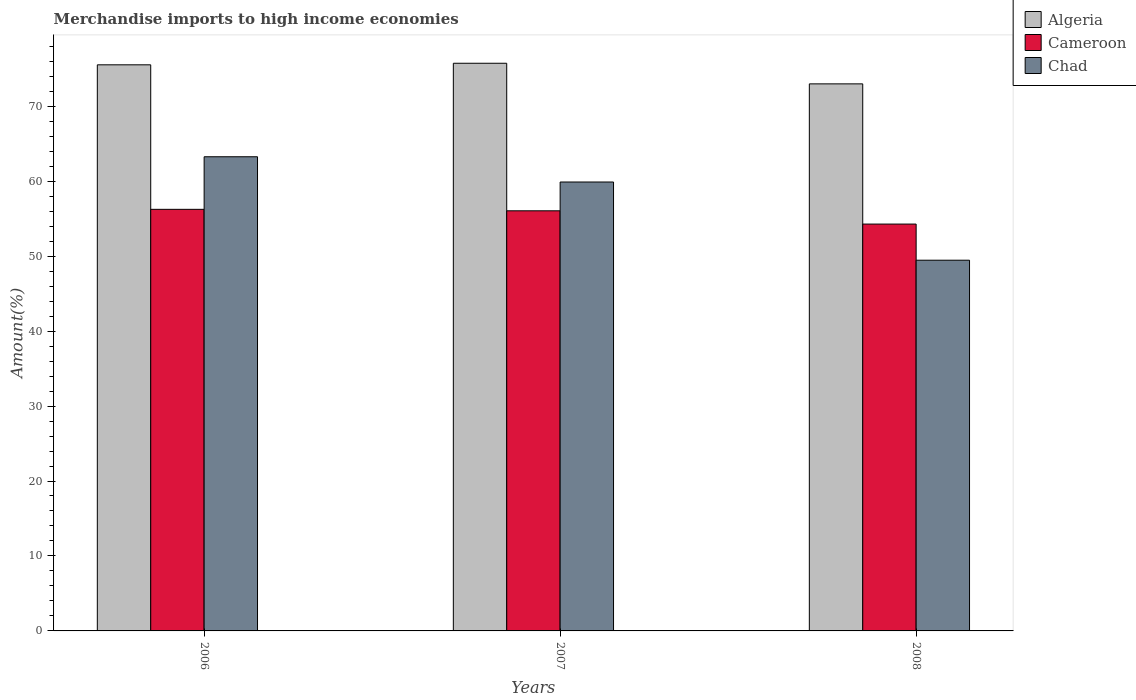How many different coloured bars are there?
Give a very brief answer. 3. How many bars are there on the 3rd tick from the left?
Make the answer very short. 3. How many bars are there on the 3rd tick from the right?
Give a very brief answer. 3. What is the percentage of amount earned from merchandise imports in Cameroon in 2006?
Your response must be concise. 56.24. Across all years, what is the maximum percentage of amount earned from merchandise imports in Algeria?
Provide a short and direct response. 75.73. Across all years, what is the minimum percentage of amount earned from merchandise imports in Cameroon?
Your response must be concise. 54.28. In which year was the percentage of amount earned from merchandise imports in Algeria maximum?
Ensure brevity in your answer.  2007. What is the total percentage of amount earned from merchandise imports in Cameroon in the graph?
Ensure brevity in your answer.  166.56. What is the difference between the percentage of amount earned from merchandise imports in Cameroon in 2006 and that in 2008?
Make the answer very short. 1.97. What is the difference between the percentage of amount earned from merchandise imports in Algeria in 2007 and the percentage of amount earned from merchandise imports in Chad in 2006?
Your answer should be compact. 12.47. What is the average percentage of amount earned from merchandise imports in Cameroon per year?
Ensure brevity in your answer.  55.52. In the year 2007, what is the difference between the percentage of amount earned from merchandise imports in Cameroon and percentage of amount earned from merchandise imports in Algeria?
Your response must be concise. -19.68. What is the ratio of the percentage of amount earned from merchandise imports in Cameroon in 2006 to that in 2007?
Give a very brief answer. 1. Is the difference between the percentage of amount earned from merchandise imports in Cameroon in 2006 and 2007 greater than the difference between the percentage of amount earned from merchandise imports in Algeria in 2006 and 2007?
Offer a very short reply. Yes. What is the difference between the highest and the second highest percentage of amount earned from merchandise imports in Chad?
Provide a succinct answer. 3.37. What is the difference between the highest and the lowest percentage of amount earned from merchandise imports in Algeria?
Offer a very short reply. 2.75. In how many years, is the percentage of amount earned from merchandise imports in Algeria greater than the average percentage of amount earned from merchandise imports in Algeria taken over all years?
Ensure brevity in your answer.  2. Is the sum of the percentage of amount earned from merchandise imports in Chad in 2007 and 2008 greater than the maximum percentage of amount earned from merchandise imports in Algeria across all years?
Offer a terse response. Yes. What does the 3rd bar from the left in 2007 represents?
Your answer should be very brief. Chad. What does the 3rd bar from the right in 2008 represents?
Ensure brevity in your answer.  Algeria. Is it the case that in every year, the sum of the percentage of amount earned from merchandise imports in Chad and percentage of amount earned from merchandise imports in Algeria is greater than the percentage of amount earned from merchandise imports in Cameroon?
Ensure brevity in your answer.  Yes. Are all the bars in the graph horizontal?
Give a very brief answer. No. How many years are there in the graph?
Your answer should be compact. 3. Are the values on the major ticks of Y-axis written in scientific E-notation?
Keep it short and to the point. No. Does the graph contain any zero values?
Offer a terse response. No. How are the legend labels stacked?
Keep it short and to the point. Vertical. What is the title of the graph?
Keep it short and to the point. Merchandise imports to high income economies. Does "Indonesia" appear as one of the legend labels in the graph?
Provide a succinct answer. No. What is the label or title of the Y-axis?
Your response must be concise. Amount(%). What is the Amount(%) in Algeria in 2006?
Ensure brevity in your answer.  75.52. What is the Amount(%) in Cameroon in 2006?
Your response must be concise. 56.24. What is the Amount(%) of Chad in 2006?
Keep it short and to the point. 63.26. What is the Amount(%) of Algeria in 2007?
Make the answer very short. 75.73. What is the Amount(%) in Cameroon in 2007?
Offer a terse response. 56.05. What is the Amount(%) in Chad in 2007?
Provide a succinct answer. 59.89. What is the Amount(%) in Algeria in 2008?
Offer a very short reply. 72.98. What is the Amount(%) of Cameroon in 2008?
Make the answer very short. 54.28. What is the Amount(%) of Chad in 2008?
Offer a terse response. 49.45. Across all years, what is the maximum Amount(%) of Algeria?
Give a very brief answer. 75.73. Across all years, what is the maximum Amount(%) of Cameroon?
Give a very brief answer. 56.24. Across all years, what is the maximum Amount(%) in Chad?
Provide a succinct answer. 63.26. Across all years, what is the minimum Amount(%) in Algeria?
Offer a terse response. 72.98. Across all years, what is the minimum Amount(%) of Cameroon?
Your answer should be very brief. 54.28. Across all years, what is the minimum Amount(%) in Chad?
Give a very brief answer. 49.45. What is the total Amount(%) in Algeria in the graph?
Provide a succinct answer. 224.23. What is the total Amount(%) of Cameroon in the graph?
Offer a terse response. 166.56. What is the total Amount(%) in Chad in the graph?
Provide a short and direct response. 172.6. What is the difference between the Amount(%) in Algeria in 2006 and that in 2007?
Provide a succinct answer. -0.21. What is the difference between the Amount(%) of Cameroon in 2006 and that in 2007?
Your answer should be compact. 0.2. What is the difference between the Amount(%) in Chad in 2006 and that in 2007?
Offer a terse response. 3.37. What is the difference between the Amount(%) in Algeria in 2006 and that in 2008?
Provide a succinct answer. 2.54. What is the difference between the Amount(%) of Cameroon in 2006 and that in 2008?
Provide a short and direct response. 1.97. What is the difference between the Amount(%) of Chad in 2006 and that in 2008?
Provide a short and direct response. 13.8. What is the difference between the Amount(%) of Algeria in 2007 and that in 2008?
Your answer should be compact. 2.75. What is the difference between the Amount(%) of Cameroon in 2007 and that in 2008?
Keep it short and to the point. 1.77. What is the difference between the Amount(%) in Chad in 2007 and that in 2008?
Offer a very short reply. 10.43. What is the difference between the Amount(%) of Algeria in 2006 and the Amount(%) of Cameroon in 2007?
Ensure brevity in your answer.  19.48. What is the difference between the Amount(%) in Algeria in 2006 and the Amount(%) in Chad in 2007?
Your answer should be very brief. 15.63. What is the difference between the Amount(%) of Cameroon in 2006 and the Amount(%) of Chad in 2007?
Make the answer very short. -3.65. What is the difference between the Amount(%) in Algeria in 2006 and the Amount(%) in Cameroon in 2008?
Your answer should be compact. 21.25. What is the difference between the Amount(%) of Algeria in 2006 and the Amount(%) of Chad in 2008?
Your answer should be very brief. 26.07. What is the difference between the Amount(%) of Cameroon in 2006 and the Amount(%) of Chad in 2008?
Give a very brief answer. 6.79. What is the difference between the Amount(%) of Algeria in 2007 and the Amount(%) of Cameroon in 2008?
Provide a succinct answer. 21.45. What is the difference between the Amount(%) of Algeria in 2007 and the Amount(%) of Chad in 2008?
Ensure brevity in your answer.  26.28. What is the difference between the Amount(%) in Cameroon in 2007 and the Amount(%) in Chad in 2008?
Keep it short and to the point. 6.59. What is the average Amount(%) of Algeria per year?
Keep it short and to the point. 74.74. What is the average Amount(%) in Cameroon per year?
Offer a terse response. 55.52. What is the average Amount(%) in Chad per year?
Your answer should be compact. 57.53. In the year 2006, what is the difference between the Amount(%) in Algeria and Amount(%) in Cameroon?
Give a very brief answer. 19.28. In the year 2006, what is the difference between the Amount(%) in Algeria and Amount(%) in Chad?
Ensure brevity in your answer.  12.27. In the year 2006, what is the difference between the Amount(%) in Cameroon and Amount(%) in Chad?
Your answer should be very brief. -7.01. In the year 2007, what is the difference between the Amount(%) of Algeria and Amount(%) of Cameroon?
Your answer should be very brief. 19.68. In the year 2007, what is the difference between the Amount(%) in Algeria and Amount(%) in Chad?
Your answer should be compact. 15.84. In the year 2007, what is the difference between the Amount(%) of Cameroon and Amount(%) of Chad?
Your response must be concise. -3.84. In the year 2008, what is the difference between the Amount(%) of Algeria and Amount(%) of Cameroon?
Provide a succinct answer. 18.7. In the year 2008, what is the difference between the Amount(%) in Algeria and Amount(%) in Chad?
Your answer should be very brief. 23.53. In the year 2008, what is the difference between the Amount(%) of Cameroon and Amount(%) of Chad?
Make the answer very short. 4.82. What is the ratio of the Amount(%) of Algeria in 2006 to that in 2007?
Keep it short and to the point. 1. What is the ratio of the Amount(%) in Cameroon in 2006 to that in 2007?
Give a very brief answer. 1. What is the ratio of the Amount(%) of Chad in 2006 to that in 2007?
Offer a terse response. 1.06. What is the ratio of the Amount(%) of Algeria in 2006 to that in 2008?
Offer a terse response. 1.03. What is the ratio of the Amount(%) in Cameroon in 2006 to that in 2008?
Your response must be concise. 1.04. What is the ratio of the Amount(%) of Chad in 2006 to that in 2008?
Ensure brevity in your answer.  1.28. What is the ratio of the Amount(%) in Algeria in 2007 to that in 2008?
Give a very brief answer. 1.04. What is the ratio of the Amount(%) in Cameroon in 2007 to that in 2008?
Offer a terse response. 1.03. What is the ratio of the Amount(%) in Chad in 2007 to that in 2008?
Keep it short and to the point. 1.21. What is the difference between the highest and the second highest Amount(%) of Algeria?
Your answer should be very brief. 0.21. What is the difference between the highest and the second highest Amount(%) of Cameroon?
Your answer should be compact. 0.2. What is the difference between the highest and the second highest Amount(%) in Chad?
Your response must be concise. 3.37. What is the difference between the highest and the lowest Amount(%) of Algeria?
Offer a very short reply. 2.75. What is the difference between the highest and the lowest Amount(%) of Cameroon?
Your answer should be very brief. 1.97. What is the difference between the highest and the lowest Amount(%) of Chad?
Your answer should be very brief. 13.8. 